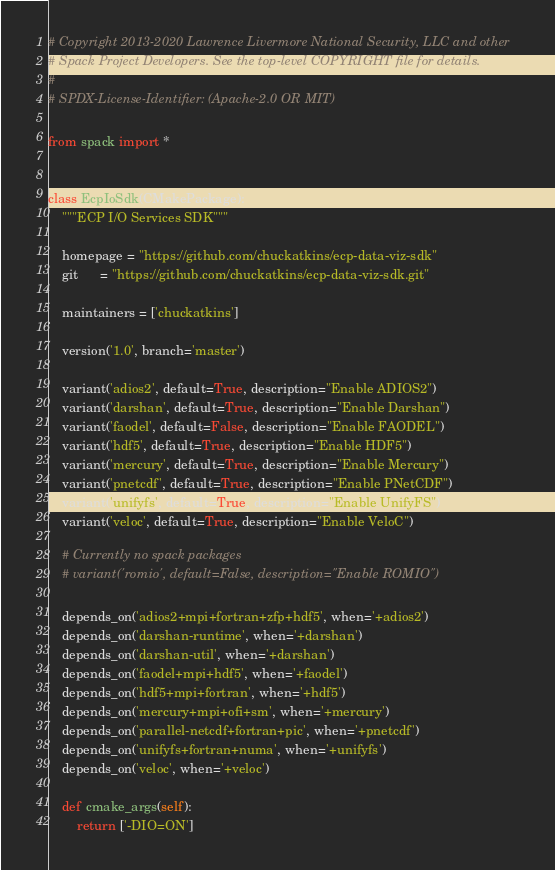Convert code to text. <code><loc_0><loc_0><loc_500><loc_500><_Python_># Copyright 2013-2020 Lawrence Livermore National Security, LLC and other
# Spack Project Developers. See the top-level COPYRIGHT file for details.
#
# SPDX-License-Identifier: (Apache-2.0 OR MIT)

from spack import *


class EcpIoSdk(CMakePackage):
    """ECP I/O Services SDK"""

    homepage = "https://github.com/chuckatkins/ecp-data-viz-sdk"
    git      = "https://github.com/chuckatkins/ecp-data-viz-sdk.git"

    maintainers = ['chuckatkins']

    version('1.0', branch='master')

    variant('adios2', default=True, description="Enable ADIOS2")
    variant('darshan', default=True, description="Enable Darshan")
    variant('faodel', default=False, description="Enable FAODEL")
    variant('hdf5', default=True, description="Enable HDF5")
    variant('mercury', default=True, description="Enable Mercury")
    variant('pnetcdf', default=True, description="Enable PNetCDF")
    variant('unifyfs', default=True, description="Enable UnifyFS")
    variant('veloc', default=True, description="Enable VeloC")

    # Currently no spack packages
    # variant('romio', default=False, description="Enable ROMIO")

    depends_on('adios2+mpi+fortran+zfp+hdf5', when='+adios2')
    depends_on('darshan-runtime', when='+darshan')
    depends_on('darshan-util', when='+darshan')
    depends_on('faodel+mpi+hdf5', when='+faodel')
    depends_on('hdf5+mpi+fortran', when='+hdf5')
    depends_on('mercury+mpi+ofi+sm', when='+mercury')
    depends_on('parallel-netcdf+fortran+pic', when='+pnetcdf')
    depends_on('unifyfs+fortran+numa', when='+unifyfs')
    depends_on('veloc', when='+veloc')

    def cmake_args(self):
        return ['-DIO=ON']
</code> 